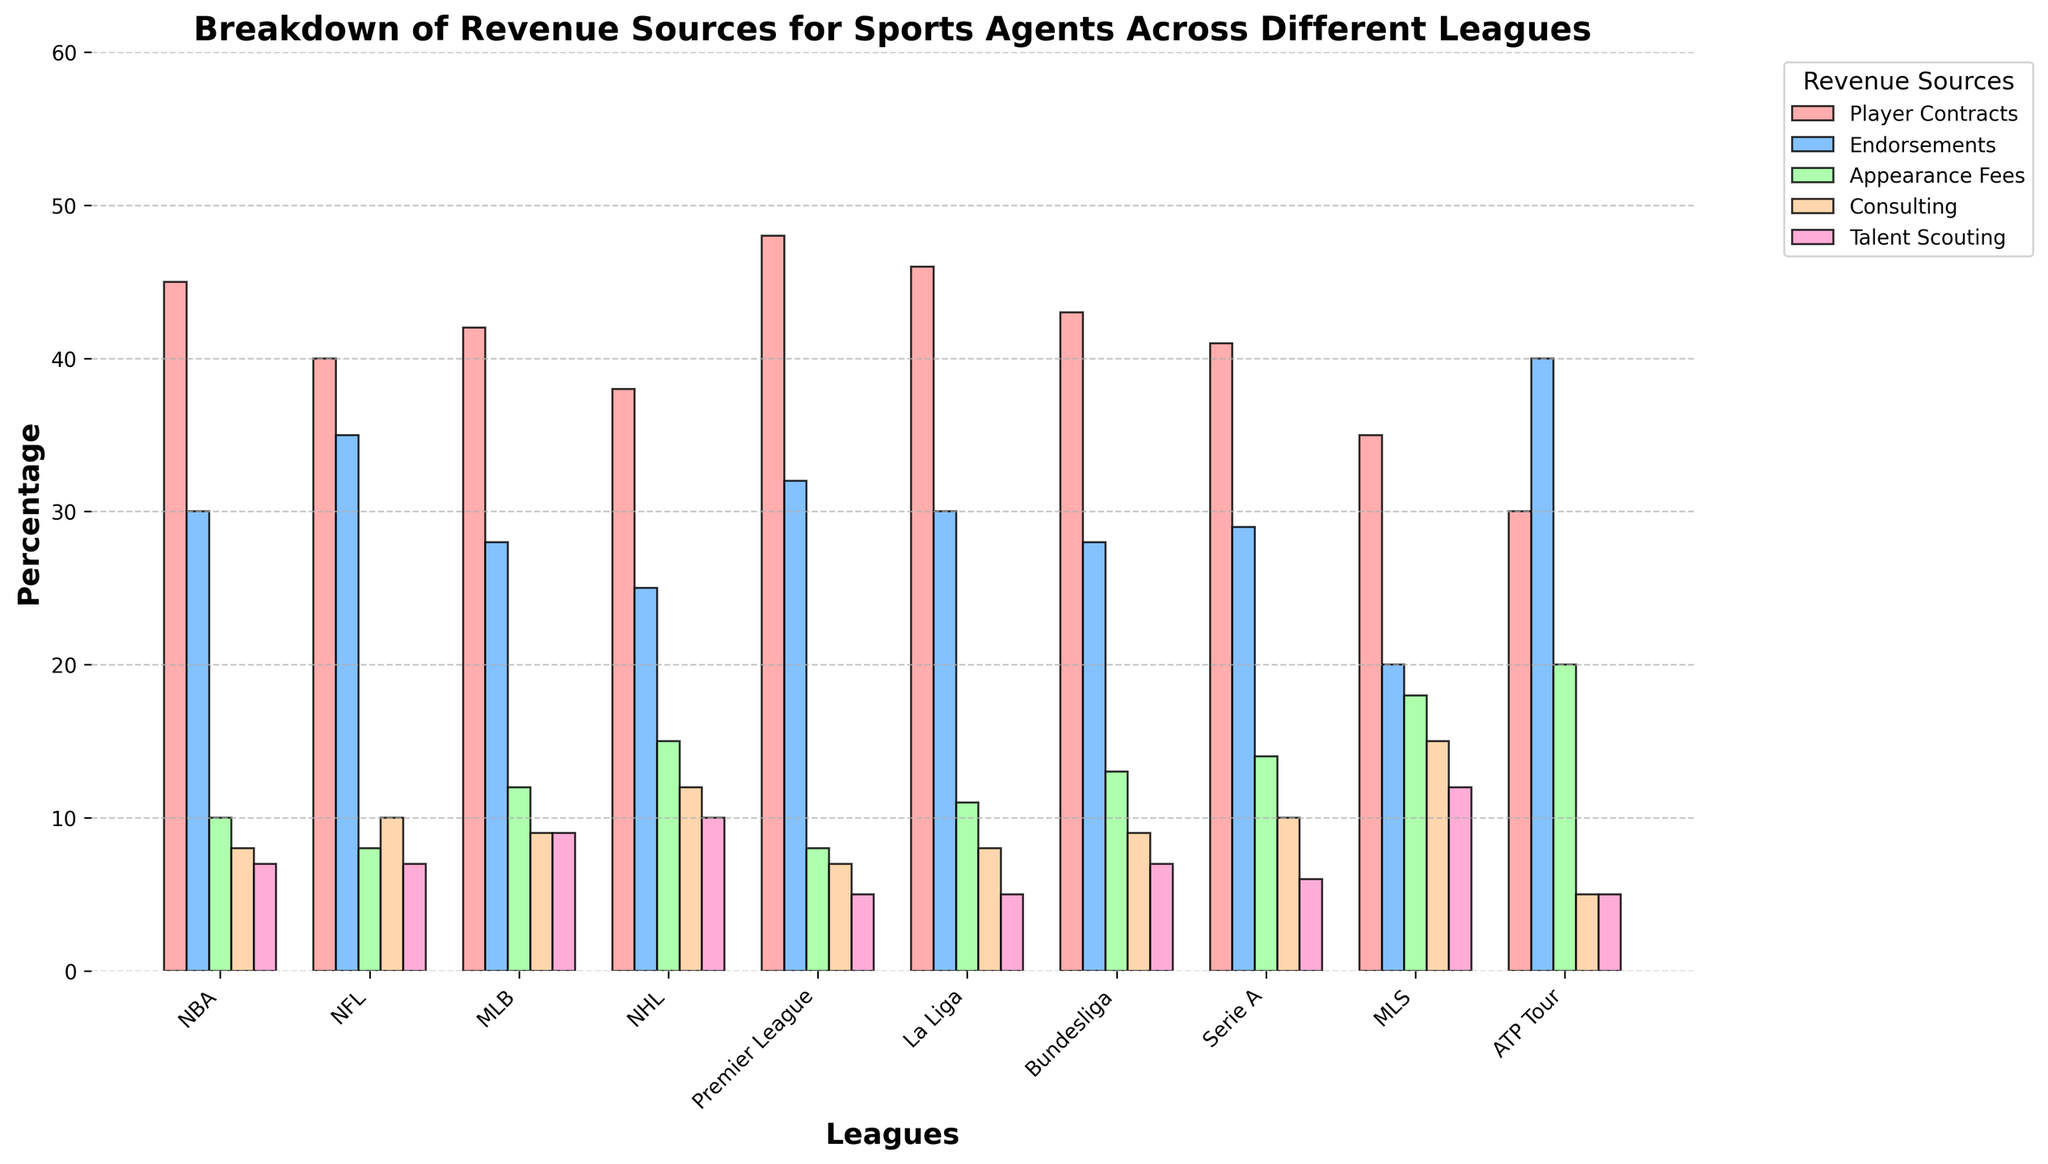Which league has the highest percentage of revenue from Player Contracts? The blue bars represent Player Contracts. The Premier League has the highest blue bar height at 48%.
Answer: Premier League Which league has the smallest percentage from Endorsements? The green bars represent Endorsements. MLS has the smallest green bar height at 20%.
Answer: MLS What's the total percentage of revenue from Consulting in La Liga and Bundesliga combined? La Liga has a purple bar at 8% and Bundesliga at 9%. Adding these gives 8% + 9%.
Answer: 17% Does any league have equal percentages from Appearance Fees and Talent Scouting? Compare the yellow and pink bars for each league. None of the leagues have these bars at the same height.
Answer: No Which league has the highest combined percentage from Endorsements and Appearance Fees? Add the green and yellow bars for each league:
NBA: 30% + 10% = 40%
NFL: 35% + 8% = 43%
MLB: 28% + 12% = 40%
NHL: 25% + 15% = 40%
Premier League: 32% + 8% = 40%
La Liga: 30% + 11% = 41%
Bundesliga: 28% + 13% = 41%
Serie A: 29% + 14% = 43%
MLS: 20% + 18% = 38%
ATP Tour: 40% + 20% = 60%
Answer: ATP Tour Which league has the highest revenue from Talent Scouting? The pink bars represent Talent Scouting, with MLS having the highest at 12%.
Answer: MLS Compare the percentages of Appearance Fees in the NBA and NHL. Which is greater, and by how much? The NBA has 10% and NHL has 15%. The difference is 15% - 10%.
Answer: NHL, by 5% What is the average revenue percentage from Player Contracts across all leagues? Sum the Player Contracts percentages for all leagues (45 + 40 + 42 + 38 + 48 + 46 + 43 + 41 + 35 + 30) = 408, then divide by 10.
Answer: 40.8% Which league has revenue equally distributed among all five sources? No league has bars of equal height across all five sources; hence, none have equally distributed revenue.
Answer: None Which league has the least reliance on Player Contracts for revenue? The blue bars represent Player Contracts, and ATP Tour has the smallest bar height at 30%.
Answer: ATP Tour 